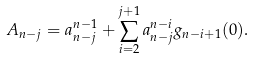<formula> <loc_0><loc_0><loc_500><loc_500>A _ { n - j } = a _ { n - j } ^ { n - 1 } + \sum _ { i = 2 } ^ { j + 1 } a _ { n - j } ^ { n - i } g _ { n - i + 1 } ( 0 ) .</formula> 